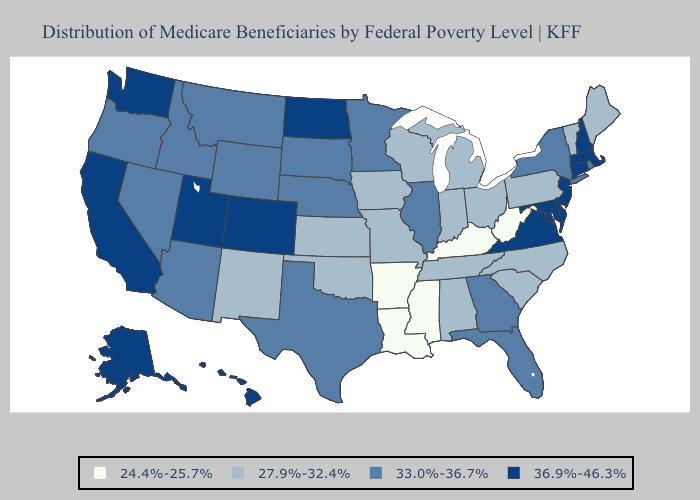Does Arkansas have the highest value in the USA?
Give a very brief answer. No. What is the lowest value in the Northeast?
Short answer required. 27.9%-32.4%. What is the lowest value in the MidWest?
Concise answer only. 27.9%-32.4%. How many symbols are there in the legend?
Keep it brief. 4. Which states have the lowest value in the South?
Give a very brief answer. Arkansas, Kentucky, Louisiana, Mississippi, West Virginia. What is the value of Tennessee?
Give a very brief answer. 27.9%-32.4%. Name the states that have a value in the range 33.0%-36.7%?
Be succinct. Arizona, Florida, Georgia, Idaho, Illinois, Minnesota, Montana, Nebraska, Nevada, New York, Oregon, Rhode Island, South Dakota, Texas, Wyoming. Is the legend a continuous bar?
Give a very brief answer. No. Name the states that have a value in the range 36.9%-46.3%?
Be succinct. Alaska, California, Colorado, Connecticut, Delaware, Hawaii, Maryland, Massachusetts, New Hampshire, New Jersey, North Dakota, Utah, Virginia, Washington. Does Delaware have the highest value in the South?
Quick response, please. Yes. What is the value of Wyoming?
Answer briefly. 33.0%-36.7%. Name the states that have a value in the range 24.4%-25.7%?
Short answer required. Arkansas, Kentucky, Louisiana, Mississippi, West Virginia. 